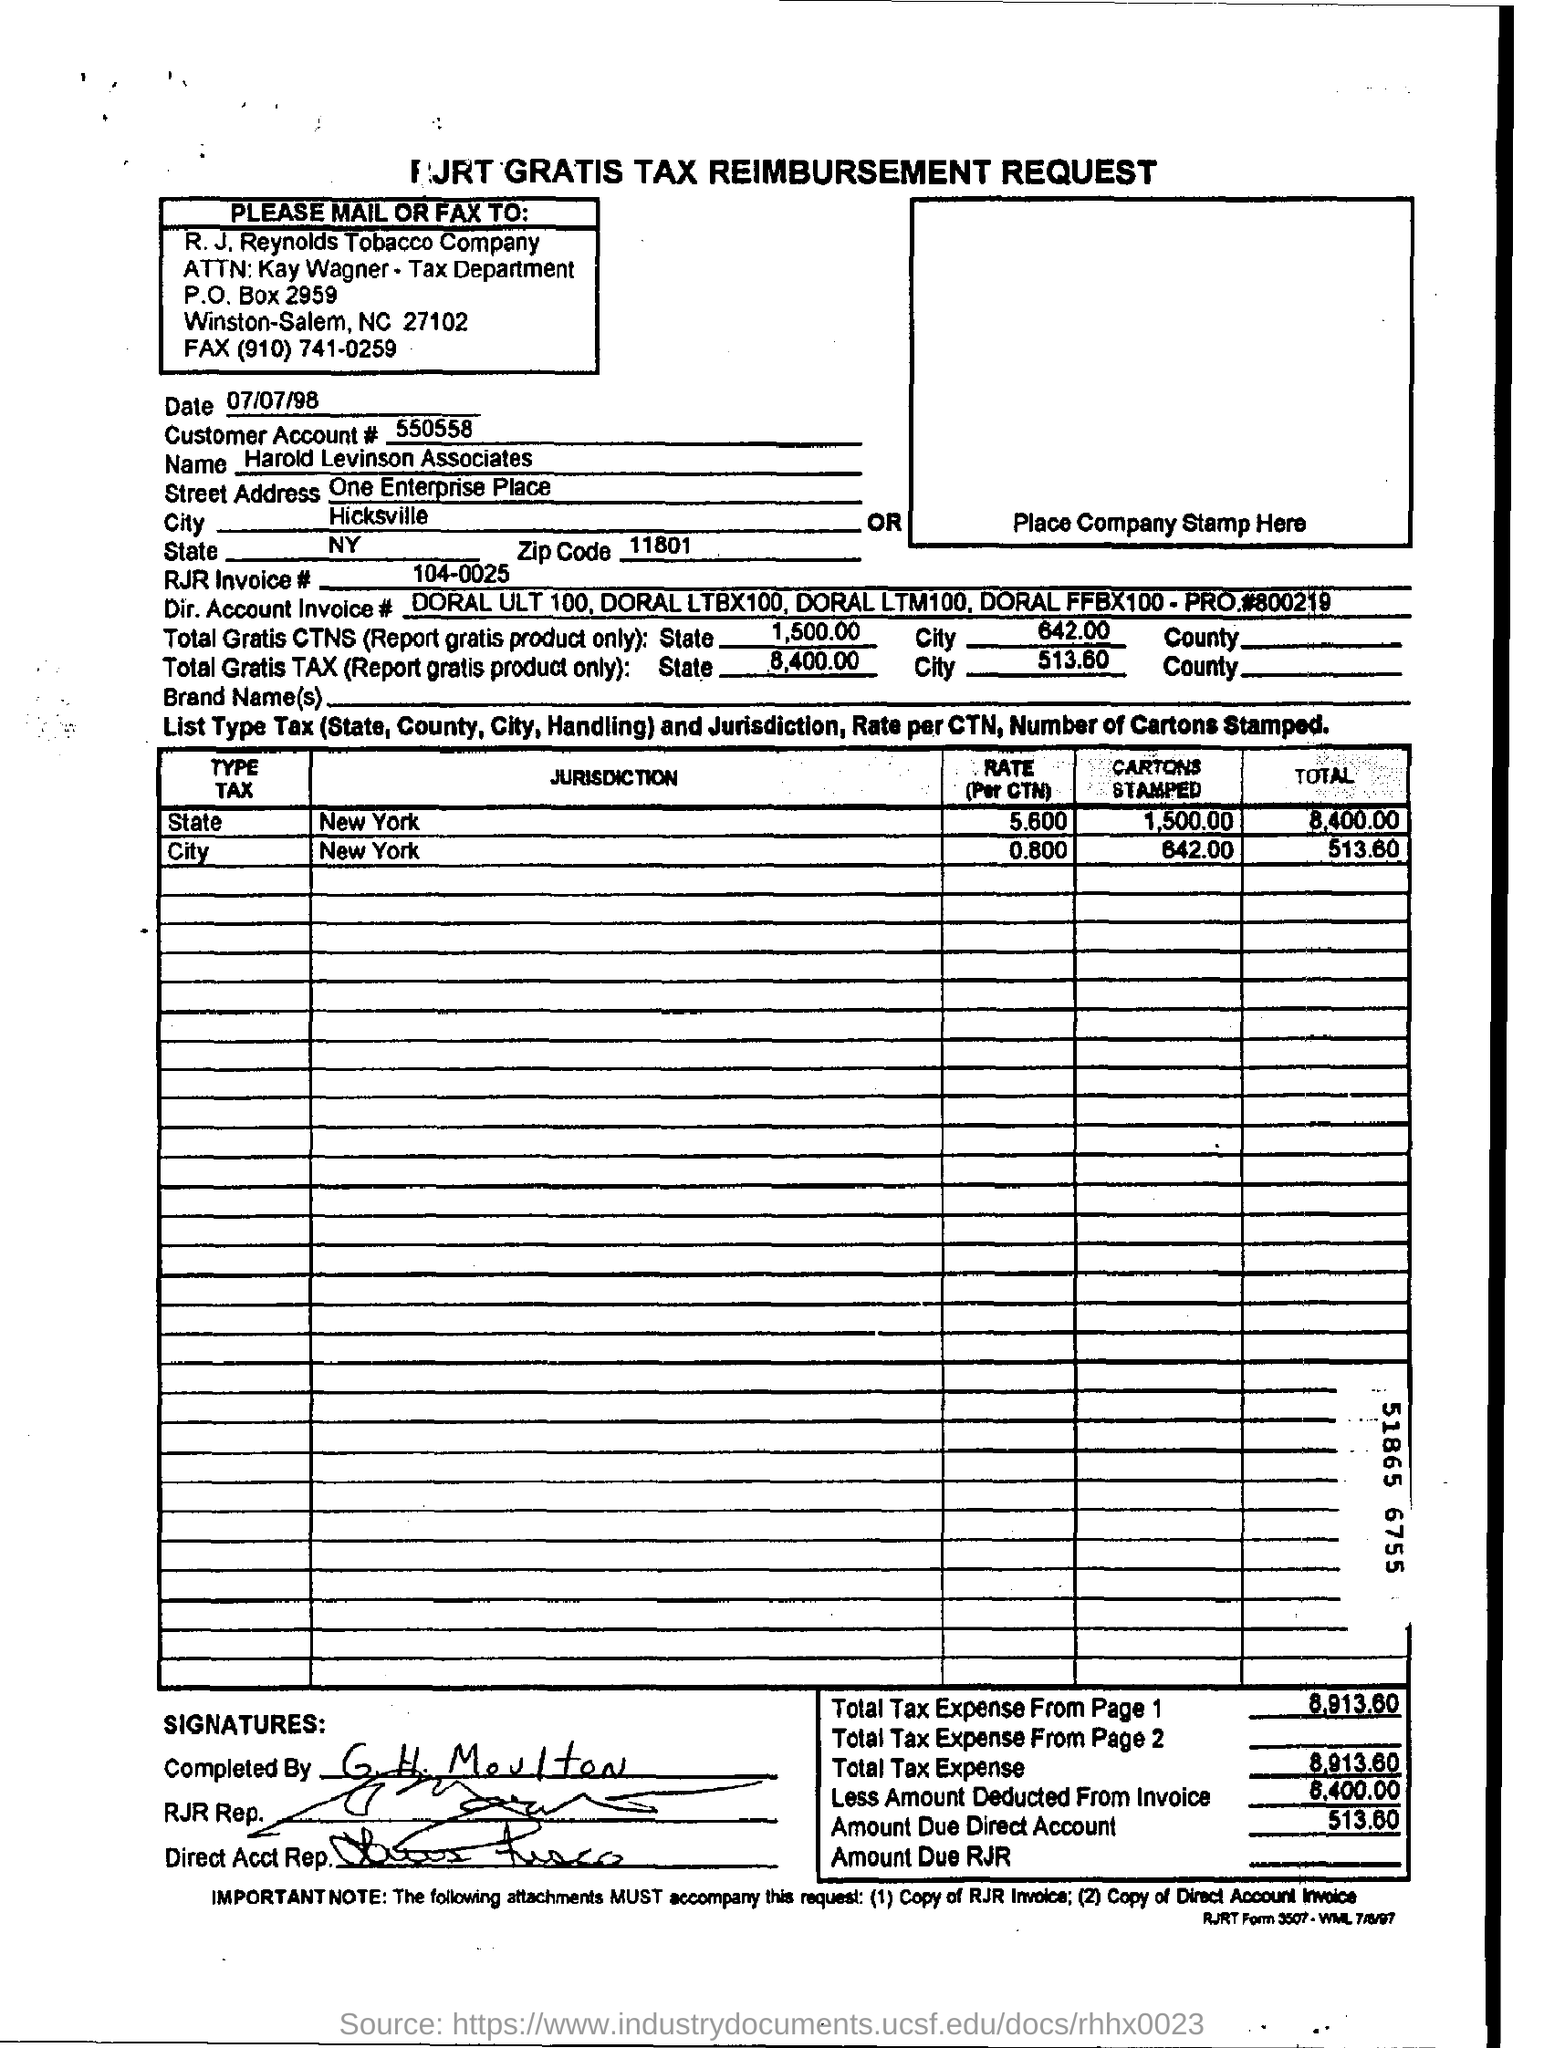What is the customer account?
Make the answer very short. 550558. What is the name of the customer?
Give a very brief answer. Harold levinson associates. What is the street adress?
Your response must be concise. One enterprise place. What is rjr invoice?
Your response must be concise. 104-0025. What is the zip code?
Provide a succinct answer. 11801. 